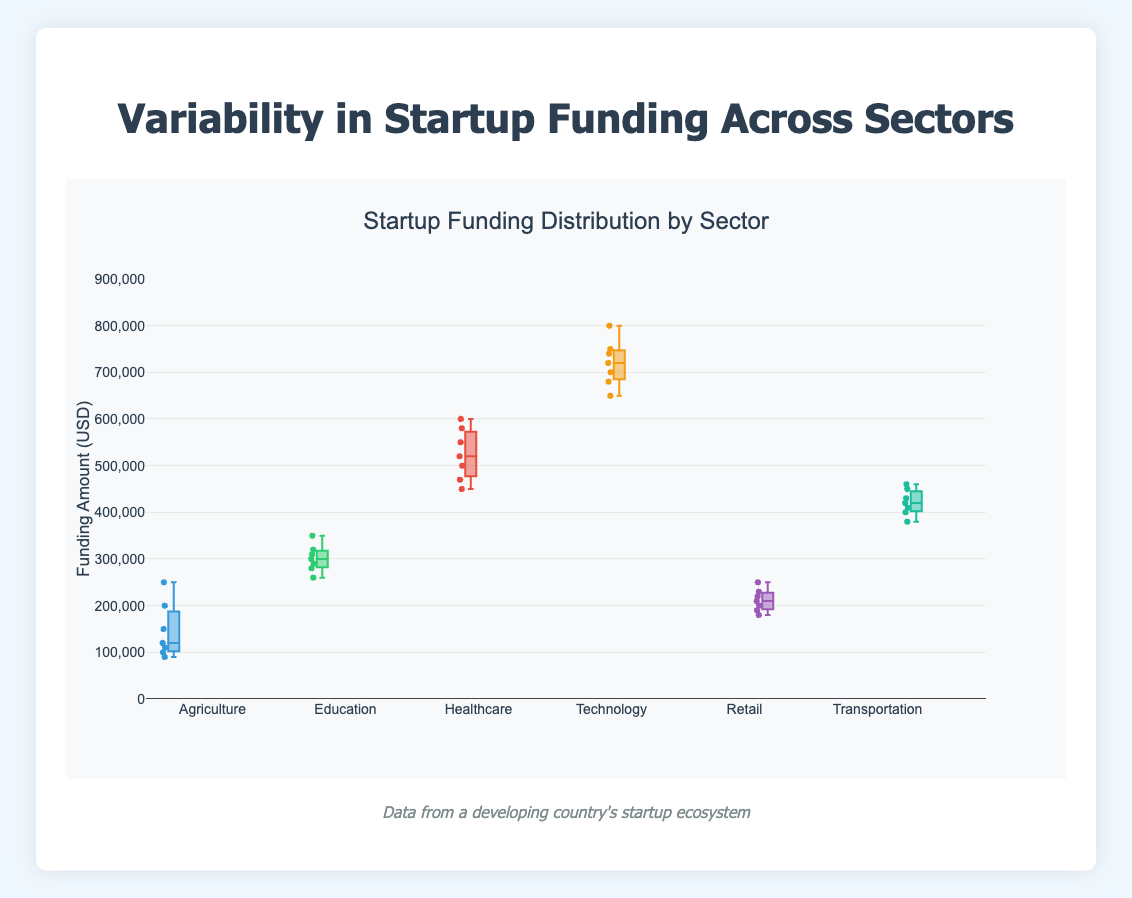What is the title of the plot? The title is written at the top of the plot. It reads "Startup Funding Distribution by Sector".
Answer: Startup Funding Distribution by Sector What is the range of funding amounts displayed on the y-axis? The y-axis ranges from 0 to 900,000, as indicated by the axis labels and ticks.
Answer: 0 to 900,000 Which sector has the most variable funding amounts? By observing the spread and the presence of boxplot whiskers, the Technology sector shows the widest range, indicating the most variability.
Answer: Technology What is the median funding amount in the Agriculture sector? The median is represented by the line inside the box of the Agriculture sector. Visually, it aligns with approximately 120,000.
Answer: 120,000 Which sector has the highest median funding amount, and what is it? By comparing the median lines in each sector's boxplot, the Technology sector has the highest median funding amount, approximately at 720,000.
Answer: Technology, 720,000 How do the funding amounts in the Healthcare sector compare to those in the Transportation sector? The Healthcare sector has higher overall funding amounts and median compared to the Transportation sector. The Healthcare median is around 520,000, whereas the Transportation median is around 420,000.
Answer: Healthcare has higher funding Which sector shows the least variability in funding amounts? By observing the boxplots, the Education sector has the shortest box and whiskers, indicating the least variability.
Answer: Education What is the approximate interquartile range (IQR) for Retail? The IQR is the range between the first quartile (Q1) and the third quartile (Q3). For Retail, Q1 is around 190,000 and Q3 is around 230,000. IQR = Q3 - Q1 = 230,000 - 190,000 = 40,000.
Answer: 40,000 Which sector has the highest outlier and what is its value? Outliers are represented by individual points outside the whiskers. The highest outlier is in Technology, around 800,000.
Answer: Technology, 800,000 